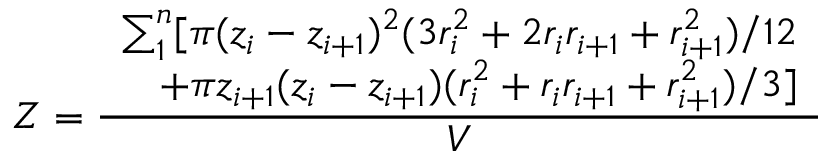Convert formula to latex. <formula><loc_0><loc_0><loc_500><loc_500>Z = \frac { \begin{array} { r } { \sum _ { 1 } ^ { n } [ \pi ( z _ { i } - z _ { i + 1 } ) ^ { 2 } ( 3 r _ { i } ^ { 2 } + 2 r _ { i } r _ { i + 1 } + r _ { i + 1 } ^ { 2 } ) / 1 2 } \\ { + \pi z _ { i + 1 } ( z _ { i } - z _ { i + 1 } ) ( r _ { i } ^ { 2 } + r _ { i } r _ { i + 1 } + r _ { i + 1 } ^ { 2 } ) / 3 ] } \end{array} } { V }</formula> 